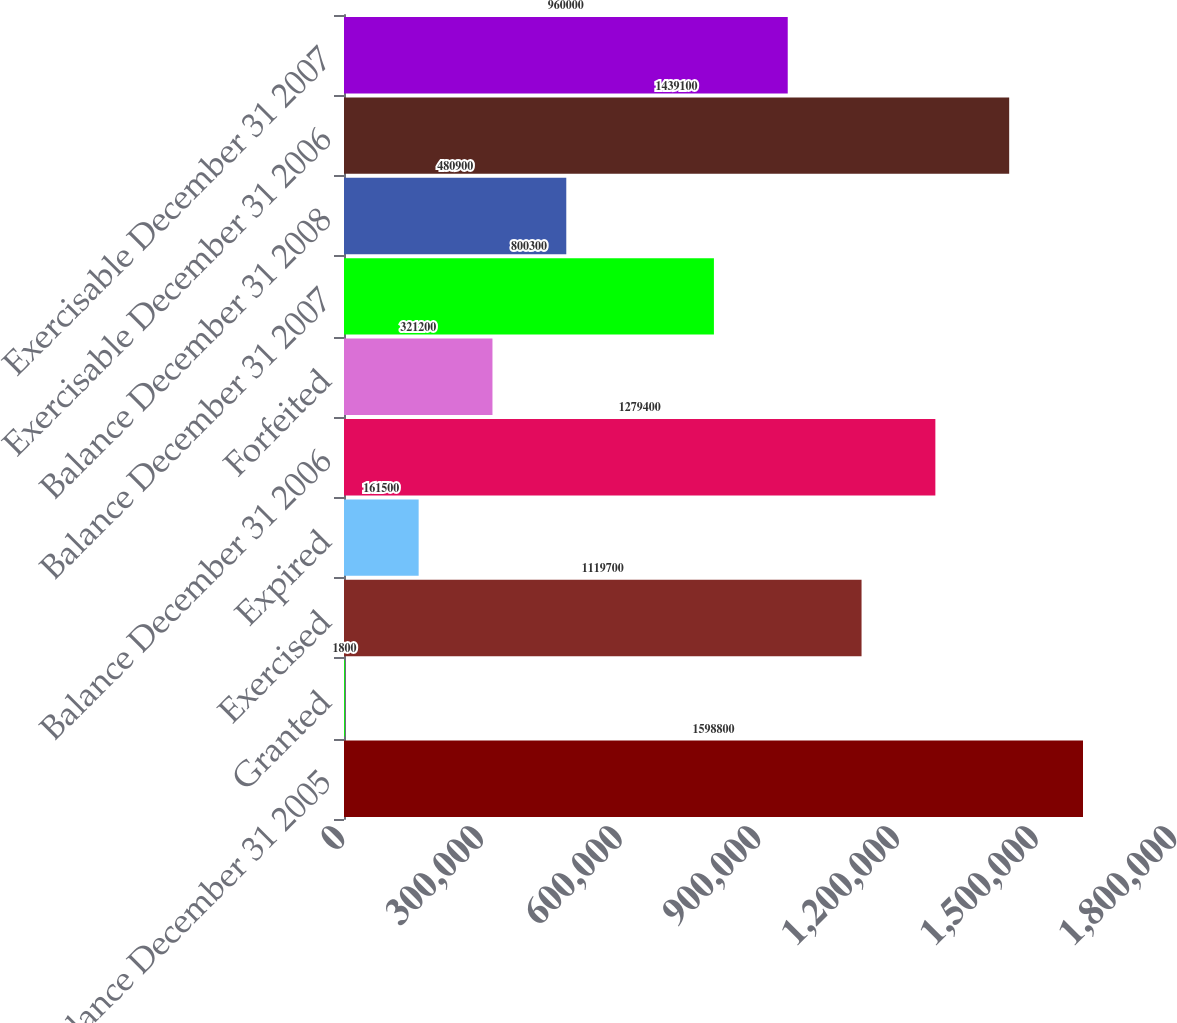Convert chart. <chart><loc_0><loc_0><loc_500><loc_500><bar_chart><fcel>Balance December 31 2005<fcel>Granted<fcel>Exercised<fcel>Expired<fcel>Balance December 31 2006<fcel>Forfeited<fcel>Balance December 31 2007<fcel>Balance December 31 2008<fcel>Exercisable December 31 2006<fcel>Exercisable December 31 2007<nl><fcel>1.5988e+06<fcel>1800<fcel>1.1197e+06<fcel>161500<fcel>1.2794e+06<fcel>321200<fcel>800300<fcel>480900<fcel>1.4391e+06<fcel>960000<nl></chart> 